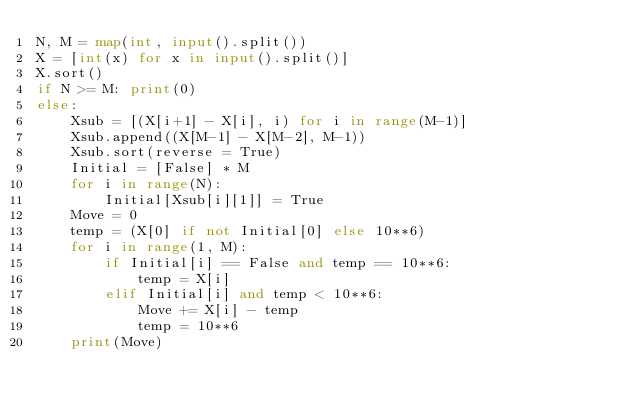Convert code to text. <code><loc_0><loc_0><loc_500><loc_500><_Python_>N, M = map(int, input().split())
X = [int(x) for x in input().split()]
X.sort()
if N >= M: print(0)
else:
    Xsub = [(X[i+1] - X[i], i) for i in range(M-1)]
    Xsub.append((X[M-1] - X[M-2], M-1))
    Xsub.sort(reverse = True)
    Initial = [False] * M
    for i in range(N):
        Initial[Xsub[i][1]] = True
    Move = 0
    temp = (X[0] if not Initial[0] else 10**6) 
    for i in range(1, M):
        if Initial[i] == False and temp == 10**6:
            temp = X[i]
        elif Initial[i] and temp < 10**6:
            Move += X[i] - temp
            temp = 10**6
    print(Move)
</code> 